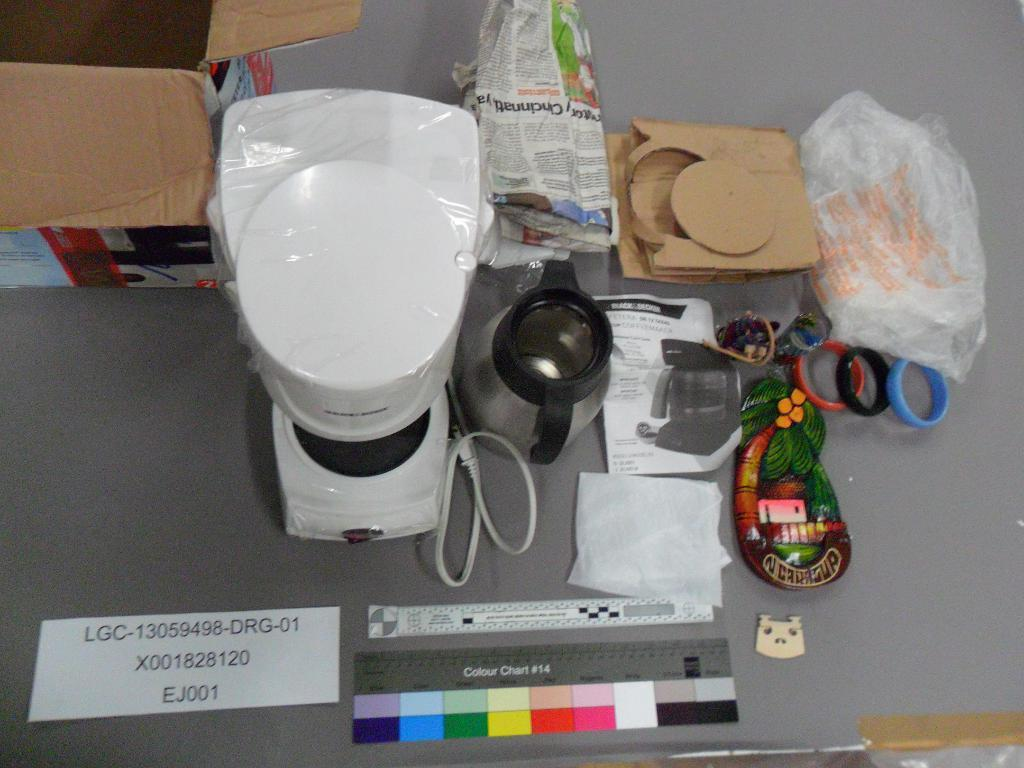<image>
Create a compact narrative representing the image presented. A group of kitchen items are on a grey table with a ruler that says Colour Chart #14. 